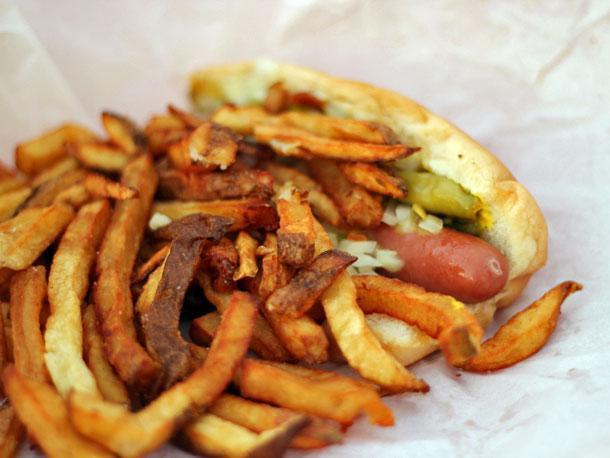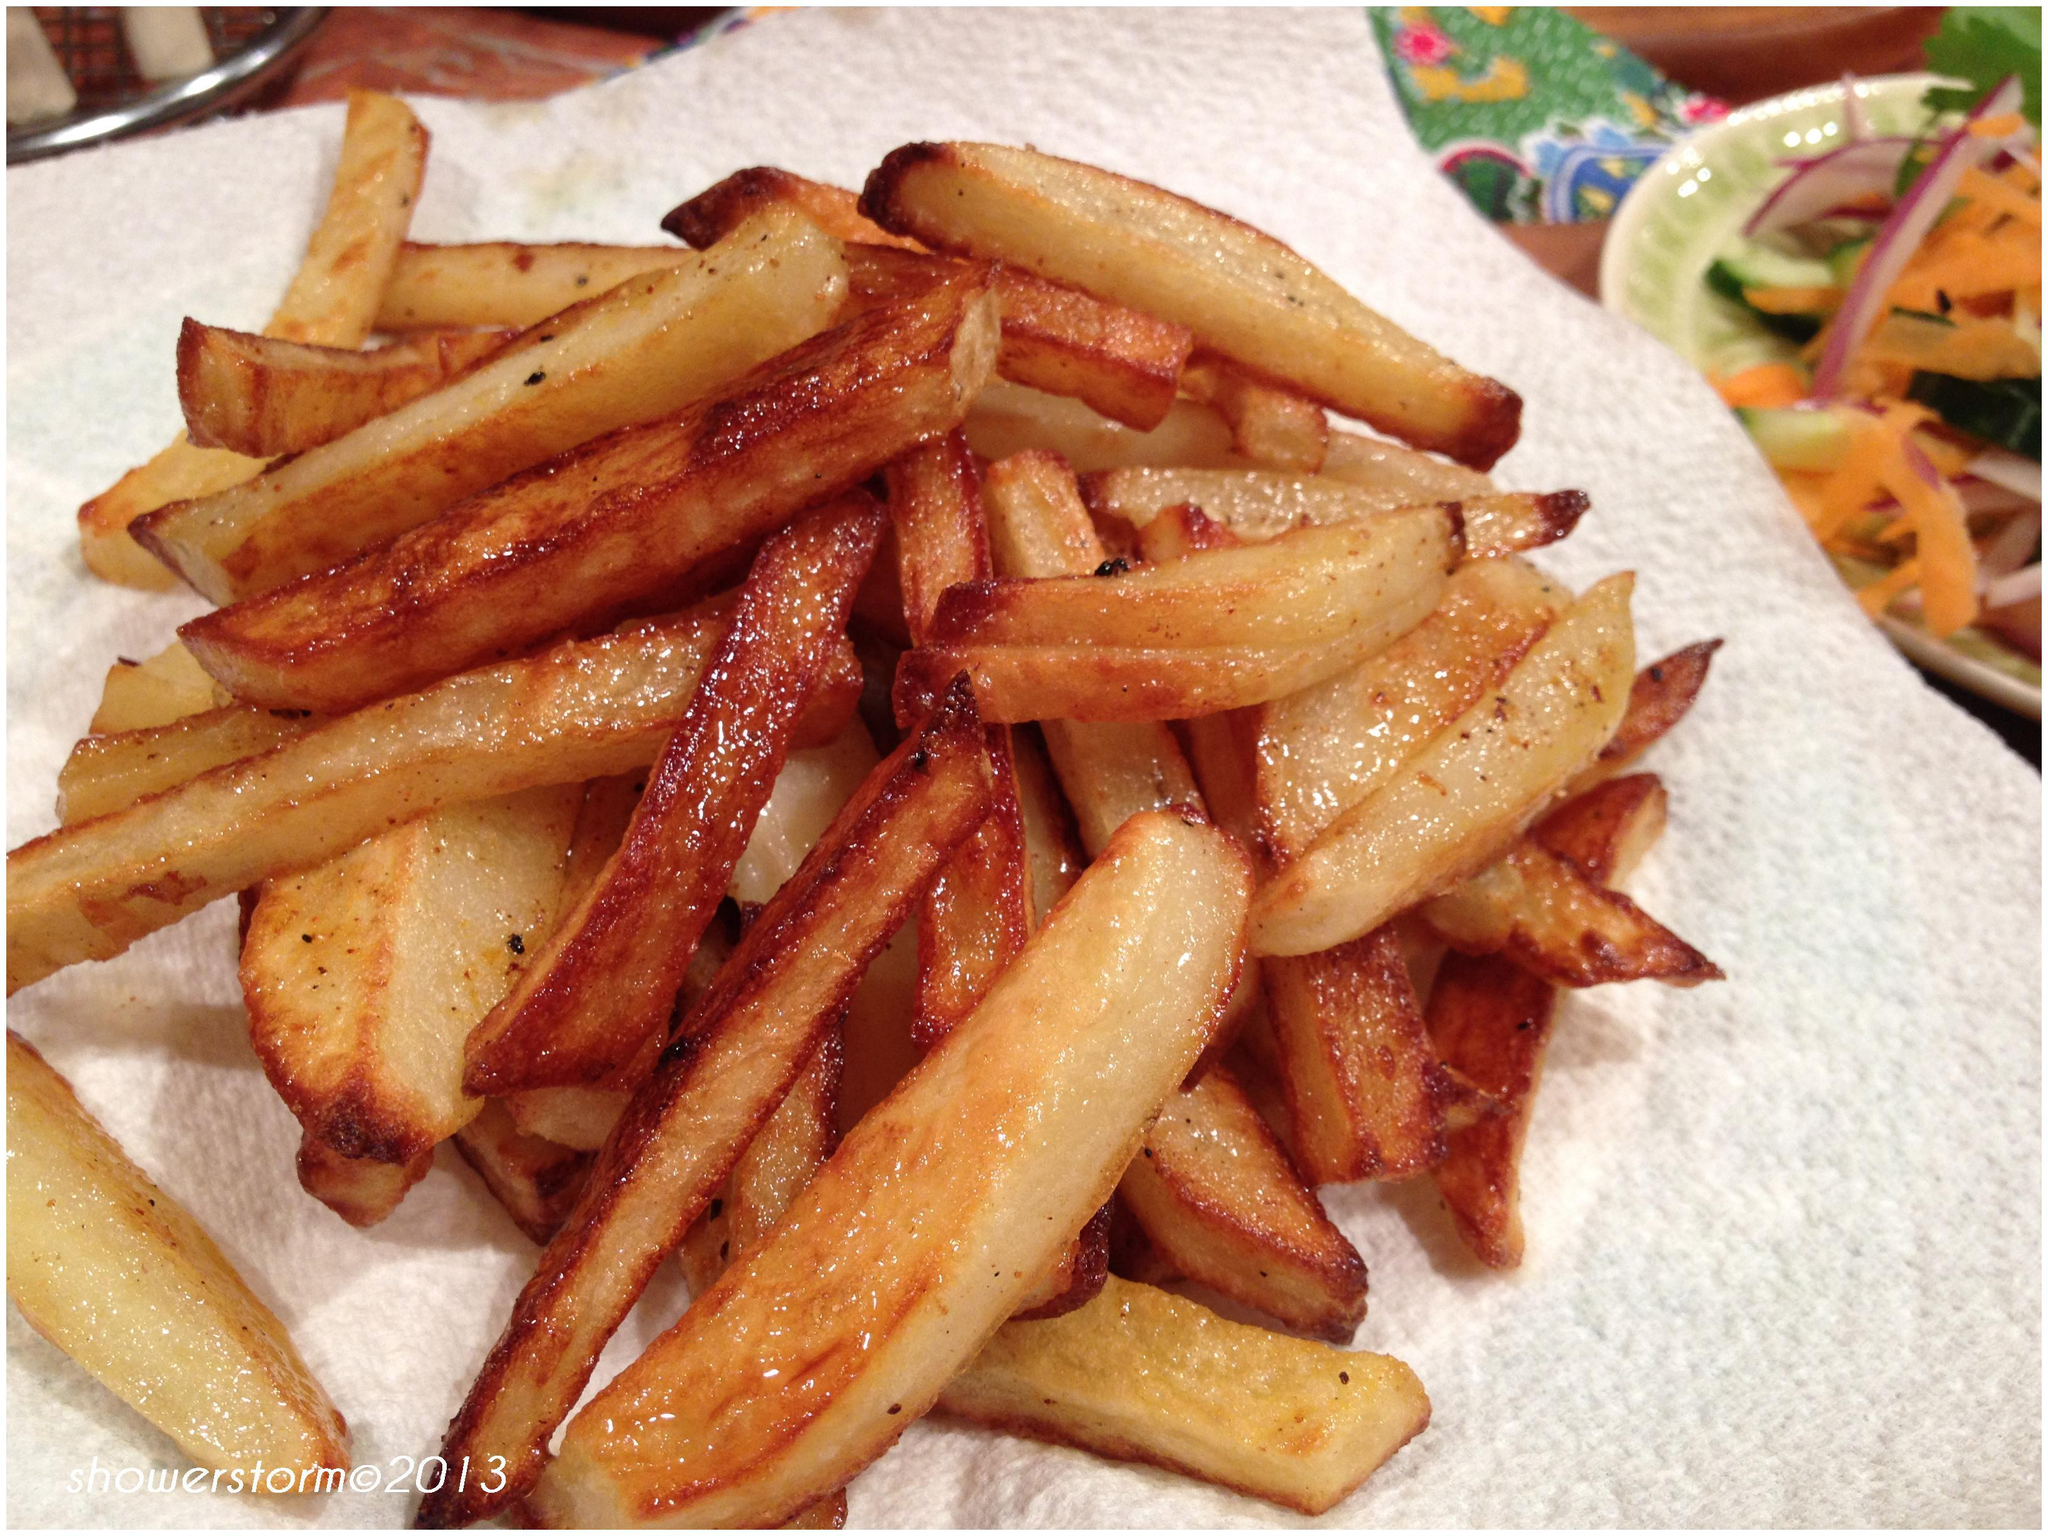The first image is the image on the left, the second image is the image on the right. Analyze the images presented: Is the assertion "The left image shows a sandwich with contents that include french fries, cheese and a round slice of meat stacked on bread." valid? Answer yes or no. No. The first image is the image on the left, the second image is the image on the right. For the images shown, is this caption "One of the items contains lettuce." true? Answer yes or no. No. 